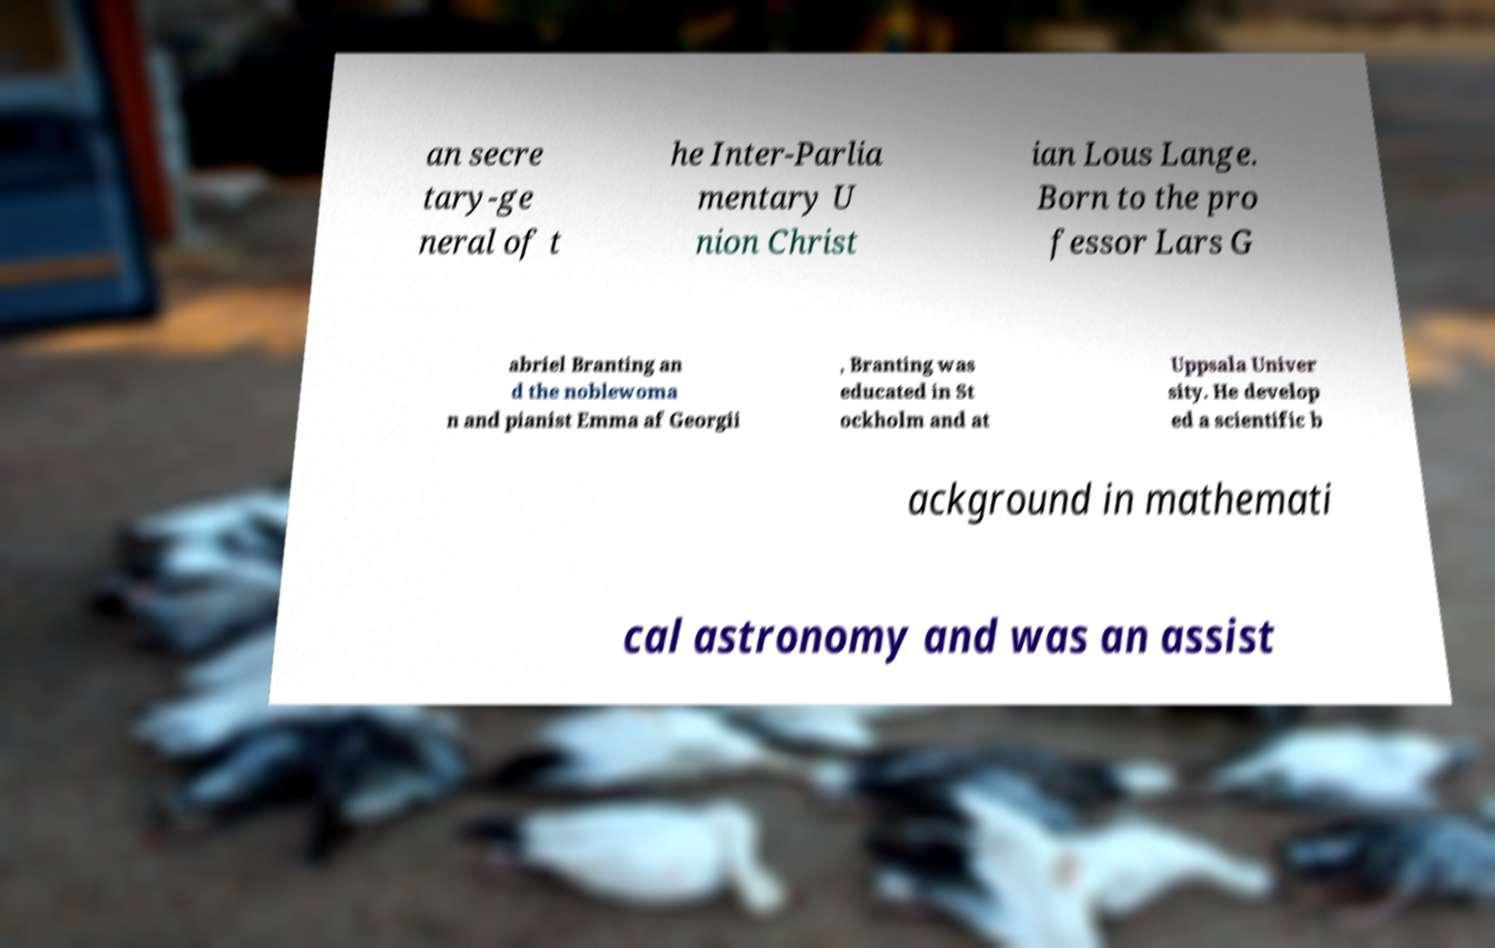Can you accurately transcribe the text from the provided image for me? an secre tary-ge neral of t he Inter-Parlia mentary U nion Christ ian Lous Lange. Born to the pro fessor Lars G abriel Branting an d the noblewoma n and pianist Emma af Georgii , Branting was educated in St ockholm and at Uppsala Univer sity. He develop ed a scientific b ackground in mathemati cal astronomy and was an assist 